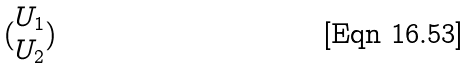<formula> <loc_0><loc_0><loc_500><loc_500>( \begin{matrix} U _ { 1 } \\ U _ { 2 } \end{matrix} )</formula> 